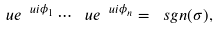<formula> <loc_0><loc_0><loc_500><loc_500>\ u e ^ { \ u i \phi _ { 1 } } \cdots \ u e ^ { \ u i \phi _ { n } } = \ s g n ( \sigma ) ,</formula> 